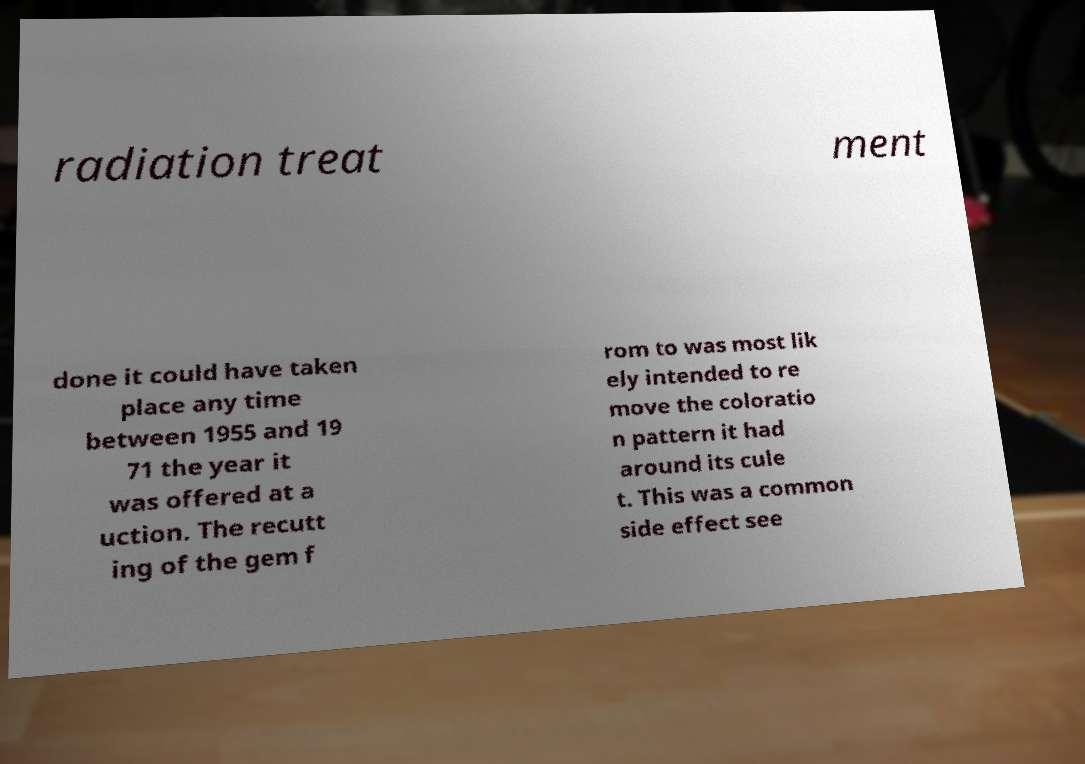I need the written content from this picture converted into text. Can you do that? radiation treat ment done it could have taken place any time between 1955 and 19 71 the year it was offered at a uction. The recutt ing of the gem f rom to was most lik ely intended to re move the coloratio n pattern it had around its cule t. This was a common side effect see 